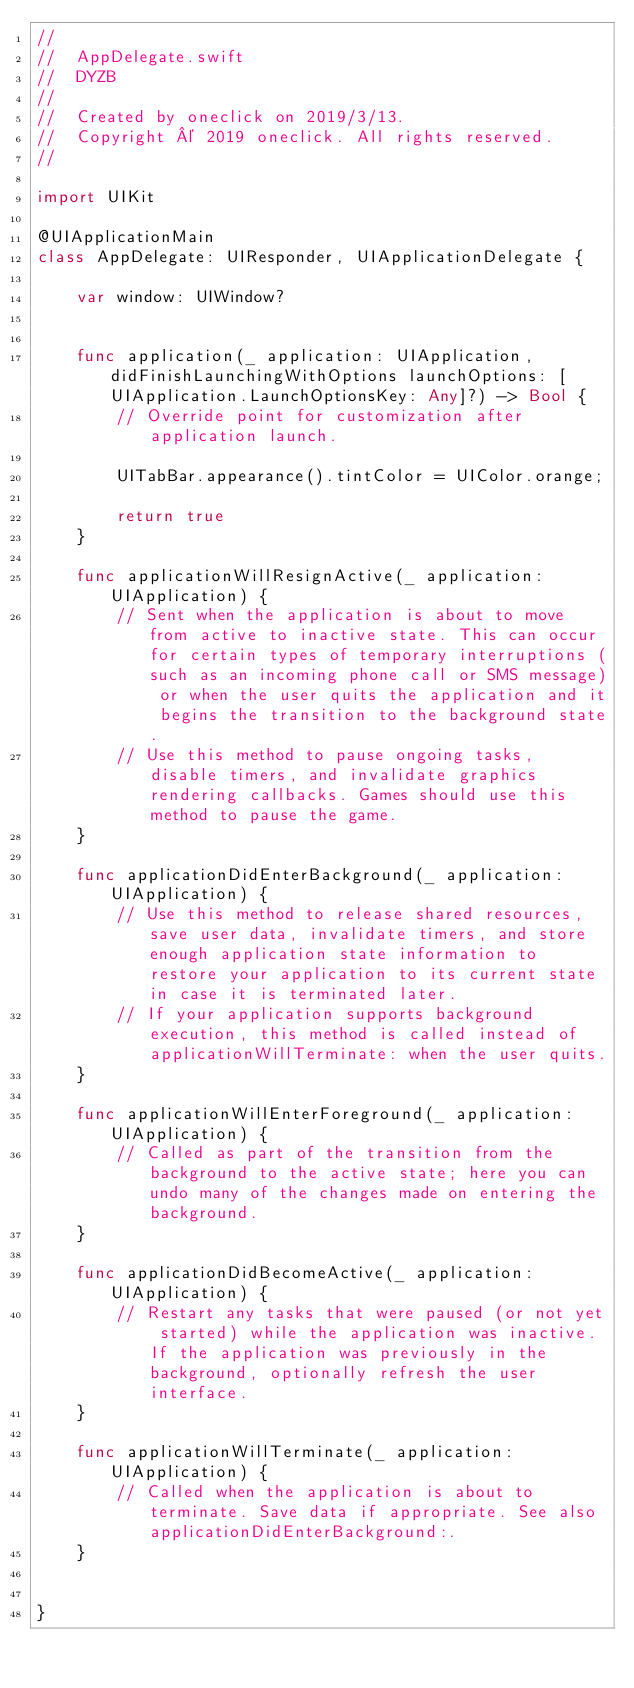Convert code to text. <code><loc_0><loc_0><loc_500><loc_500><_Swift_>//
//  AppDelegate.swift
//  DYZB
//
//  Created by oneclick on 2019/3/13.
//  Copyright © 2019 oneclick. All rights reserved.
//

import UIKit

@UIApplicationMain
class AppDelegate: UIResponder, UIApplicationDelegate {

    var window: UIWindow?


    func application(_ application: UIApplication, didFinishLaunchingWithOptions launchOptions: [UIApplication.LaunchOptionsKey: Any]?) -> Bool {
        // Override point for customization after application launch.
        
        UITabBar.appearance().tintColor = UIColor.orange;
        
        return true
    }

    func applicationWillResignActive(_ application: UIApplication) {
        // Sent when the application is about to move from active to inactive state. This can occur for certain types of temporary interruptions (such as an incoming phone call or SMS message) or when the user quits the application and it begins the transition to the background state.
        // Use this method to pause ongoing tasks, disable timers, and invalidate graphics rendering callbacks. Games should use this method to pause the game.
    }

    func applicationDidEnterBackground(_ application: UIApplication) {
        // Use this method to release shared resources, save user data, invalidate timers, and store enough application state information to restore your application to its current state in case it is terminated later.
        // If your application supports background execution, this method is called instead of applicationWillTerminate: when the user quits.
    }

    func applicationWillEnterForeground(_ application: UIApplication) {
        // Called as part of the transition from the background to the active state; here you can undo many of the changes made on entering the background.
    }

    func applicationDidBecomeActive(_ application: UIApplication) {
        // Restart any tasks that were paused (or not yet started) while the application was inactive. If the application was previously in the background, optionally refresh the user interface.
    }

    func applicationWillTerminate(_ application: UIApplication) {
        // Called when the application is about to terminate. Save data if appropriate. See also applicationDidEnterBackground:.
    }


}

</code> 